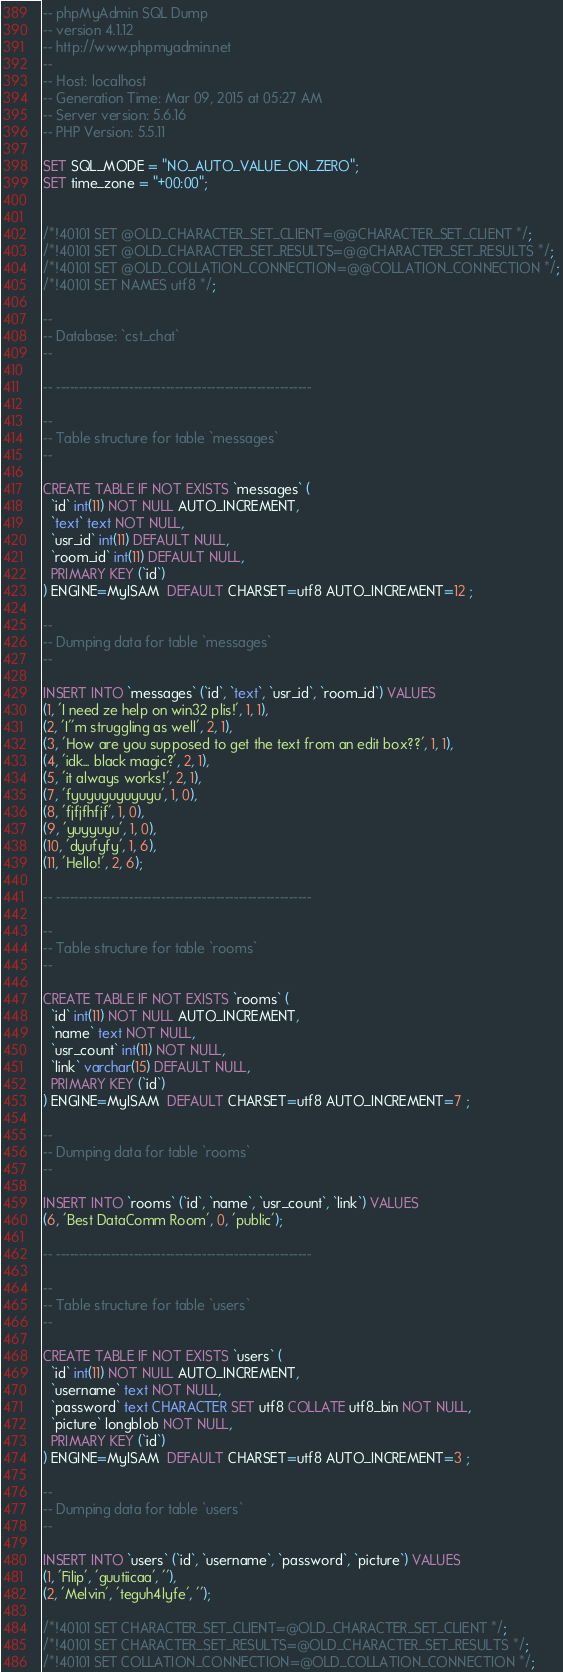Convert code to text. <code><loc_0><loc_0><loc_500><loc_500><_SQL_>-- phpMyAdmin SQL Dump
-- version 4.1.12
-- http://www.phpmyadmin.net
--
-- Host: localhost
-- Generation Time: Mar 09, 2015 at 05:27 AM
-- Server version: 5.6.16
-- PHP Version: 5.5.11

SET SQL_MODE = "NO_AUTO_VALUE_ON_ZERO";
SET time_zone = "+00:00";


/*!40101 SET @OLD_CHARACTER_SET_CLIENT=@@CHARACTER_SET_CLIENT */;
/*!40101 SET @OLD_CHARACTER_SET_RESULTS=@@CHARACTER_SET_RESULTS */;
/*!40101 SET @OLD_COLLATION_CONNECTION=@@COLLATION_CONNECTION */;
/*!40101 SET NAMES utf8 */;

--
-- Database: `cst_chat`
--

-- --------------------------------------------------------

--
-- Table structure for table `messages`
--

CREATE TABLE IF NOT EXISTS `messages` (
  `id` int(11) NOT NULL AUTO_INCREMENT,
  `text` text NOT NULL,
  `usr_id` int(11) DEFAULT NULL,
  `room_id` int(11) DEFAULT NULL,
  PRIMARY KEY (`id`)
) ENGINE=MyISAM  DEFAULT CHARSET=utf8 AUTO_INCREMENT=12 ;

--
-- Dumping data for table `messages`
--

INSERT INTO `messages` (`id`, `text`, `usr_id`, `room_id`) VALUES
(1, 'I need ze help on win32 plis!', 1, 1),
(2, 'I''m struggling as well', 2, 1),
(3, 'How are you supposed to get the text from an edit box??', 1, 1),
(4, 'idk... black magic?', 2, 1),
(5, 'it always works!', 2, 1),
(7, 'fyuyuyuyuyuyu', 1, 0),
(8, 'fjfjfhfjf', 1, 0),
(9, 'yuyyuyu', 1, 0),
(10, 'dyufyfy', 1, 6),
(11, 'Hello!', 2, 6);

-- --------------------------------------------------------

--
-- Table structure for table `rooms`
--

CREATE TABLE IF NOT EXISTS `rooms` (
  `id` int(11) NOT NULL AUTO_INCREMENT,
  `name` text NOT NULL,
  `usr_count` int(11) NOT NULL,
  `link` varchar(15) DEFAULT NULL,
  PRIMARY KEY (`id`)
) ENGINE=MyISAM  DEFAULT CHARSET=utf8 AUTO_INCREMENT=7 ;

--
-- Dumping data for table `rooms`
--

INSERT INTO `rooms` (`id`, `name`, `usr_count`, `link`) VALUES
(6, 'Best DataComm Room', 0, 'public');

-- --------------------------------------------------------

--
-- Table structure for table `users`
--

CREATE TABLE IF NOT EXISTS `users` (
  `id` int(11) NOT NULL AUTO_INCREMENT,
  `username` text NOT NULL,
  `password` text CHARACTER SET utf8 COLLATE utf8_bin NOT NULL,
  `picture` longblob NOT NULL,
  PRIMARY KEY (`id`)
) ENGINE=MyISAM  DEFAULT CHARSET=utf8 AUTO_INCREMENT=3 ;

--
-- Dumping data for table `users`
--

INSERT INTO `users` (`id`, `username`, `password`, `picture`) VALUES
(1, 'Filip', 'guutiicaa', ''),
(2, 'Melvin', 'teguh4lyfe', '');

/*!40101 SET CHARACTER_SET_CLIENT=@OLD_CHARACTER_SET_CLIENT */;
/*!40101 SET CHARACTER_SET_RESULTS=@OLD_CHARACTER_SET_RESULTS */;
/*!40101 SET COLLATION_CONNECTION=@OLD_COLLATION_CONNECTION */;
</code> 